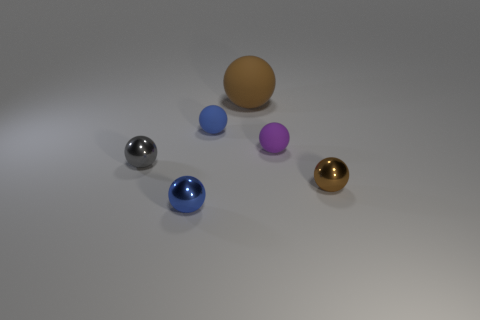What is the shape of the other metal thing that is the same color as the large object?
Ensure brevity in your answer.  Sphere. There is a tiny metal object to the right of the blue matte sphere; is it the same color as the big sphere?
Offer a terse response. Yes. Are there any other things of the same color as the large matte ball?
Ensure brevity in your answer.  Yes. There is a brown object that is on the left side of the tiny purple thing that is left of the small shiny ball right of the big brown matte object; what is its size?
Ensure brevity in your answer.  Large. There is a small metallic object that is both in front of the gray object and on the left side of the tiny blue rubber object; what is its shape?
Your answer should be compact. Sphere. Are there the same number of blue objects that are to the right of the big brown thing and blue metallic balls that are behind the tiny brown sphere?
Your answer should be compact. Yes. Are there any tiny purple objects that have the same material as the large object?
Keep it short and to the point. Yes. Is the thing on the left side of the tiny blue metal object made of the same material as the small brown thing?
Provide a short and direct response. Yes. There is a object that is both to the right of the blue matte ball and behind the tiny purple matte ball; what is its size?
Keep it short and to the point. Large. The large matte sphere has what color?
Ensure brevity in your answer.  Brown. 